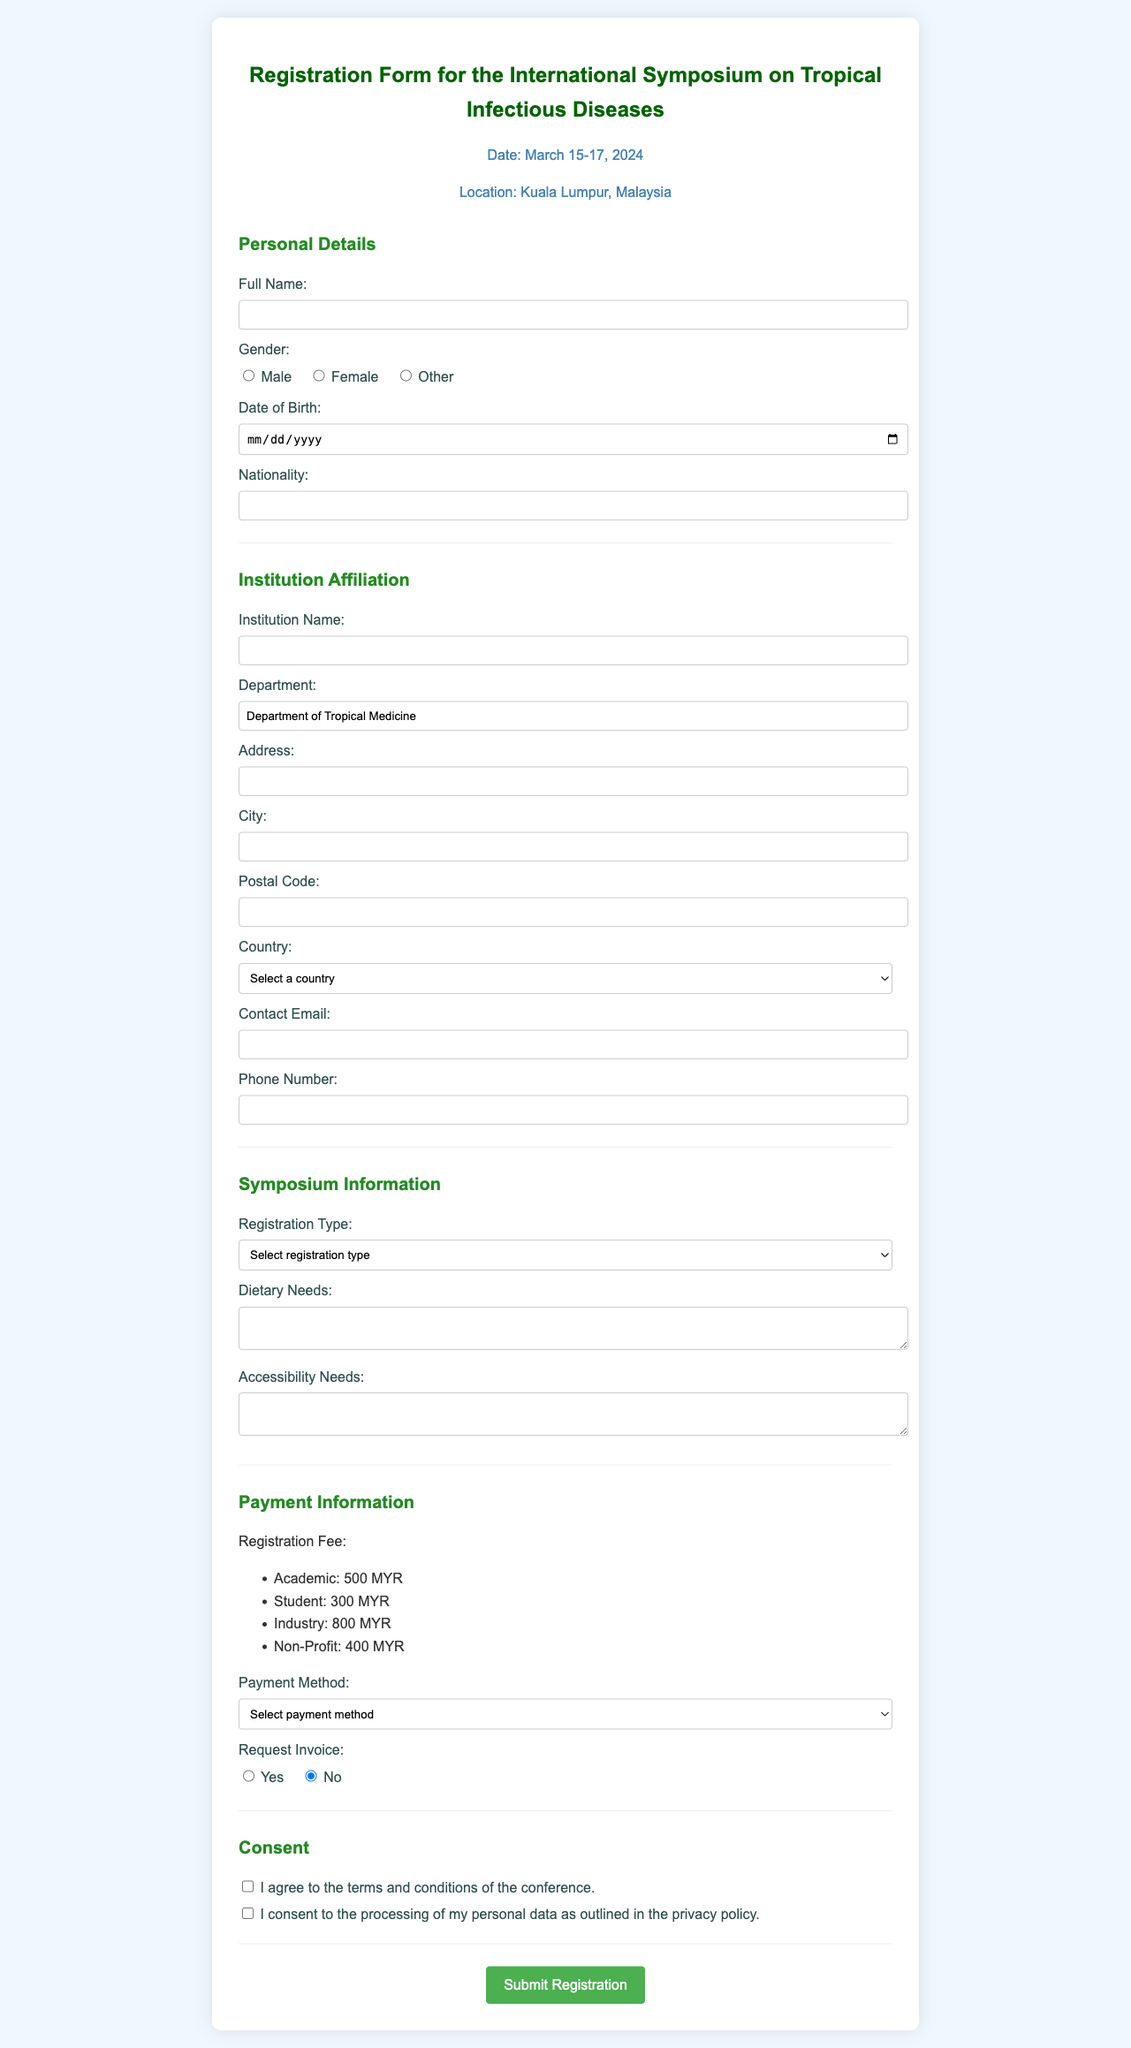What is the title of the event? The title is mentioned at the beginning of the form, clearly indicating the type of event.
Answer: International Symposium on Tropical Infectious Diseases Registration What are the dates of the symposium? The symposium dates are specified in the info section of the document.
Answer: March 15-17, 2024 What is the registration fee for students? The fees are listed under the Payment Information section, separated by categories.
Answer: 300 MYR Which country is the event location? The location is indicated in the info section of the document.
Answer: Malaysia What is the required field for the full name? This is part of the Personal Details section where a full name is needed.
Answer: Full Name What types of registration types are available? The document lists different categories of registration types for participants.
Answer: Academic, Student, Industry, Non-Profit Is there a field to specify dietary needs? This is mentioned under the Symposium Information section, indicating special requirements.
Answer: Yes What payment methods are accepted? The document outlines the payment methods available in the Payment Information section.
Answer: Credit Card, Bank Transfer, PayPal Are there consent boxes in the form? The form includes a section for participants to agree to terms and data processing.
Answer: Yes 